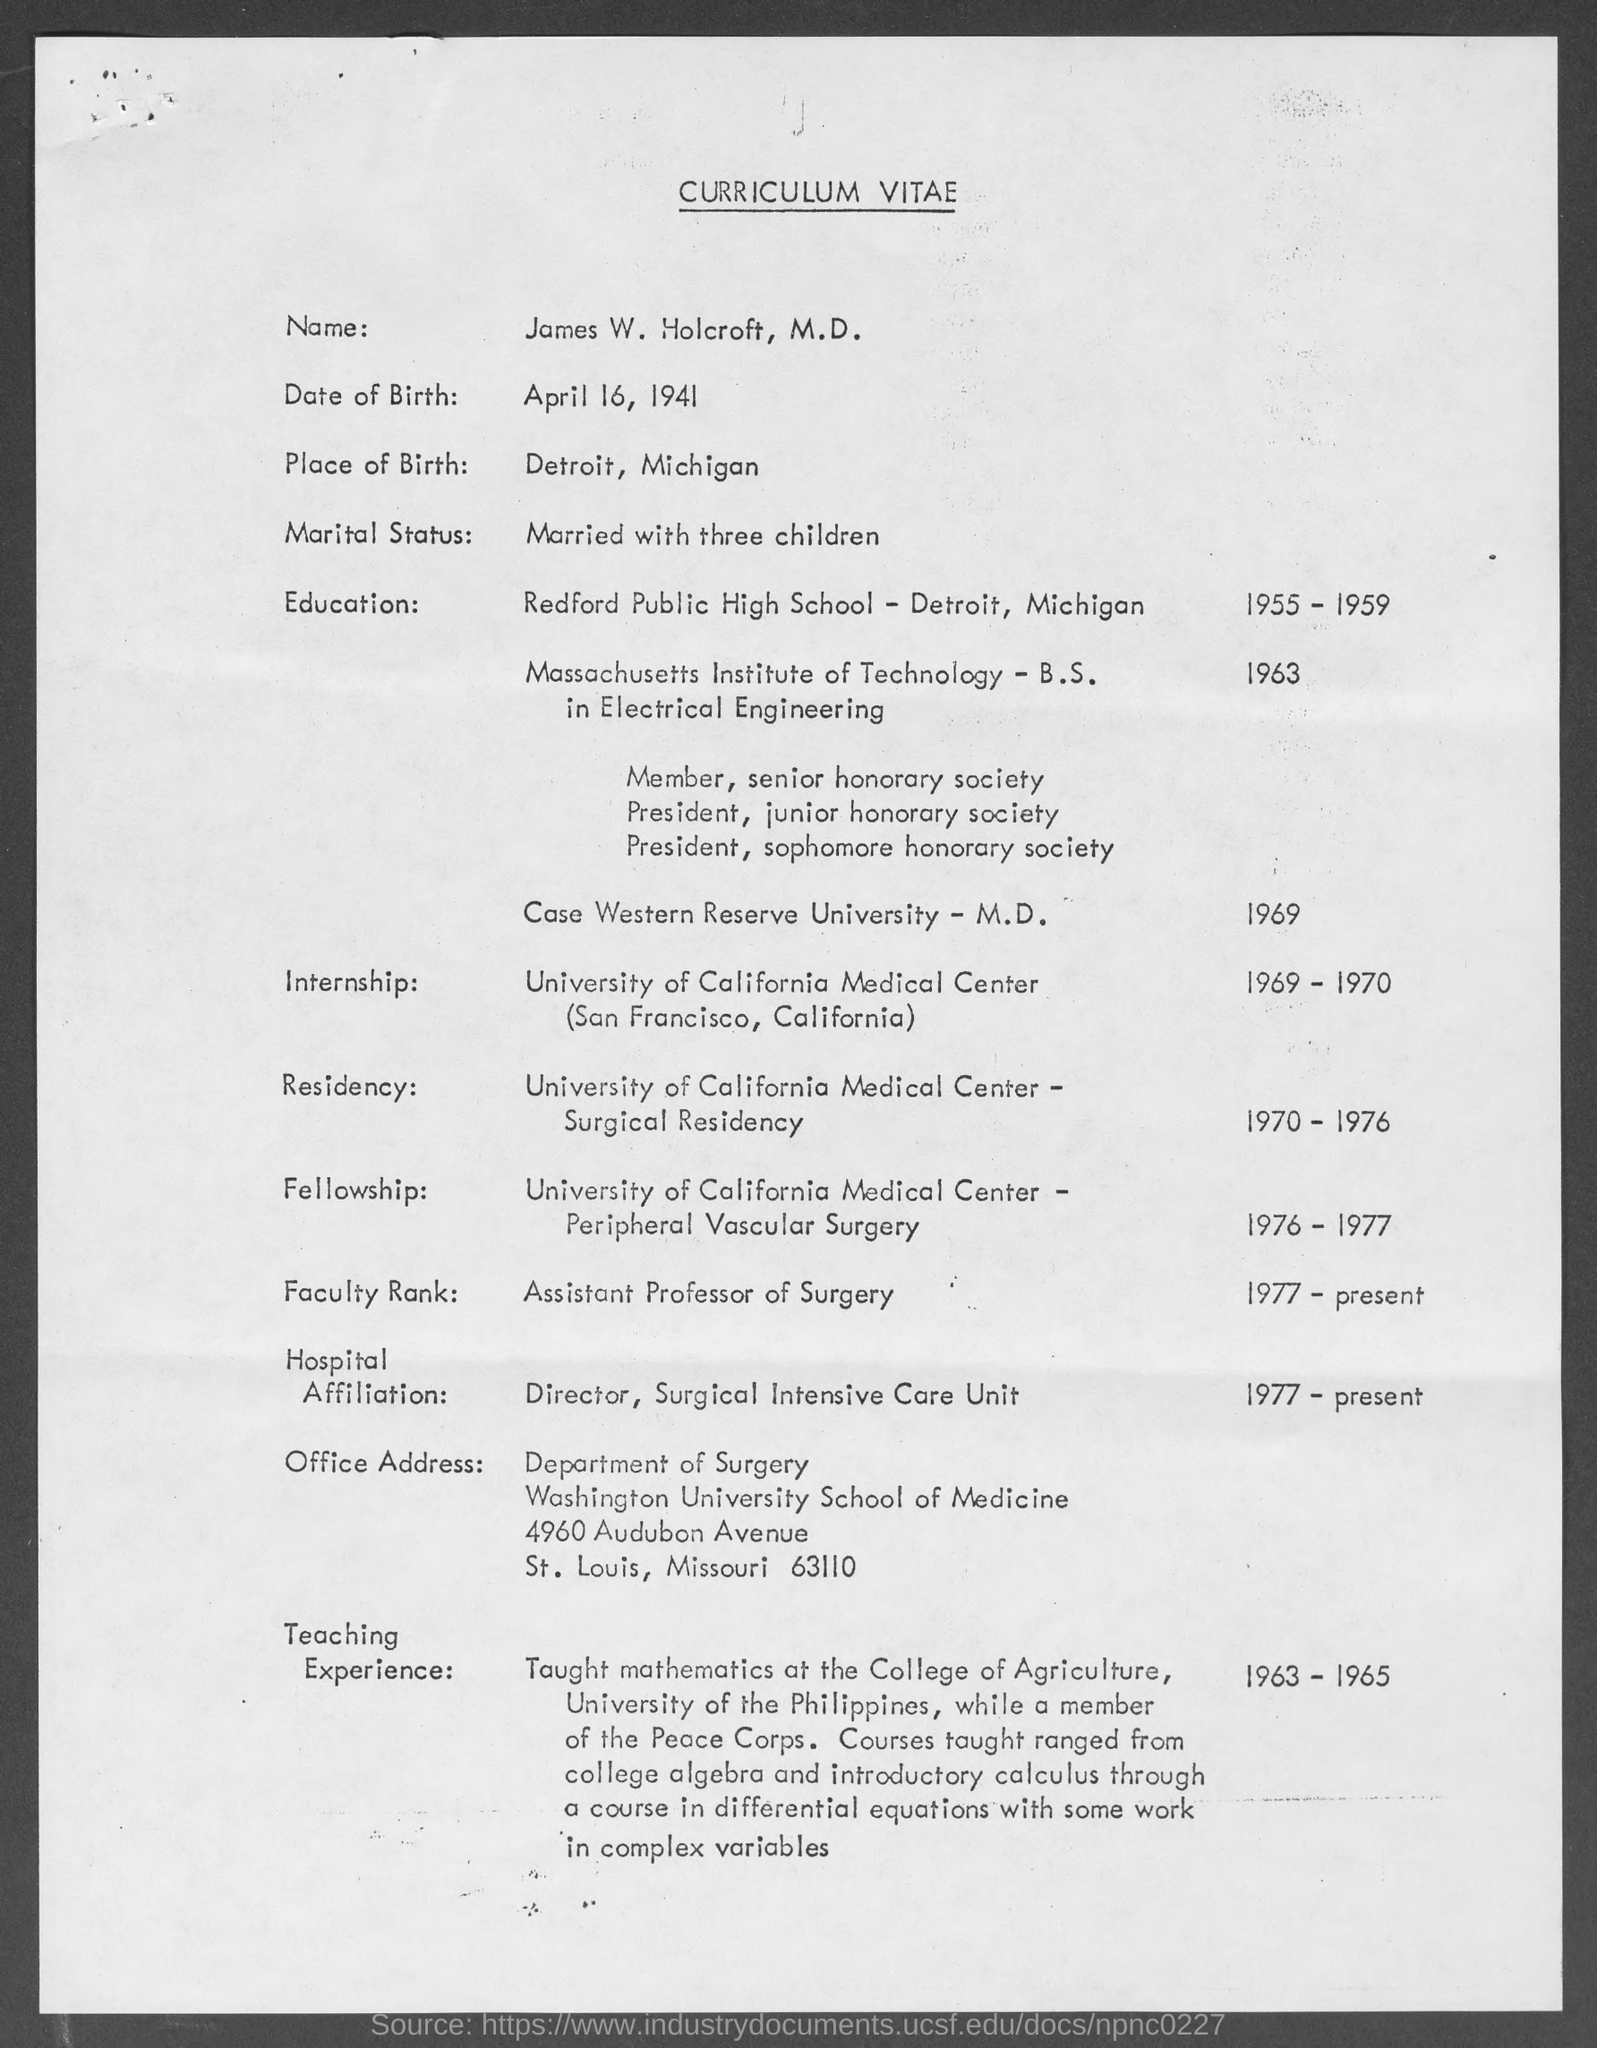What type of document this ?
Offer a very short reply. Curriculum Vitae. Where is the place birth ?
Provide a succinct answer. Detroit, Michigan. Which year he completed internship?
Your answer should be very brief. 1969-1970. 